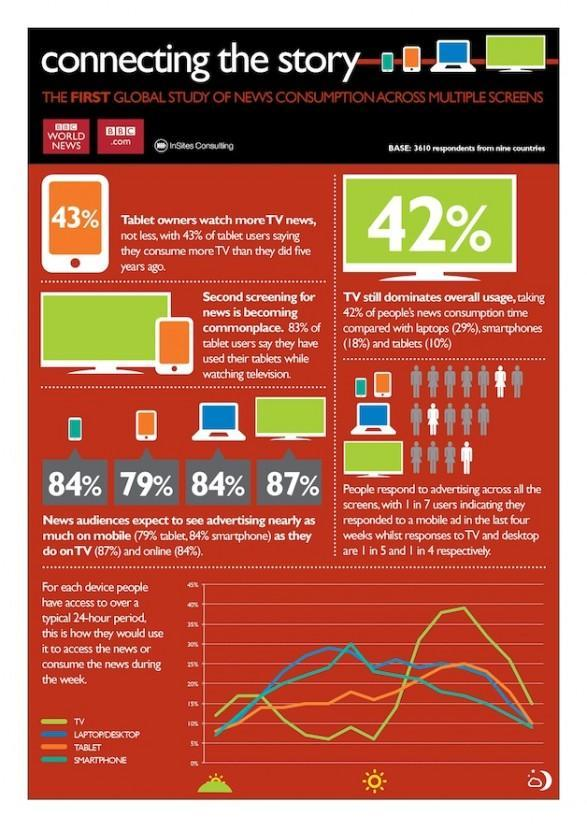What percentage of news audiences expect to see advertising on mobile and tablet,  taken together?
Answer the question with a short phrase. 163% What percentage of news audiences expect to see advertising on mobile? 84% 